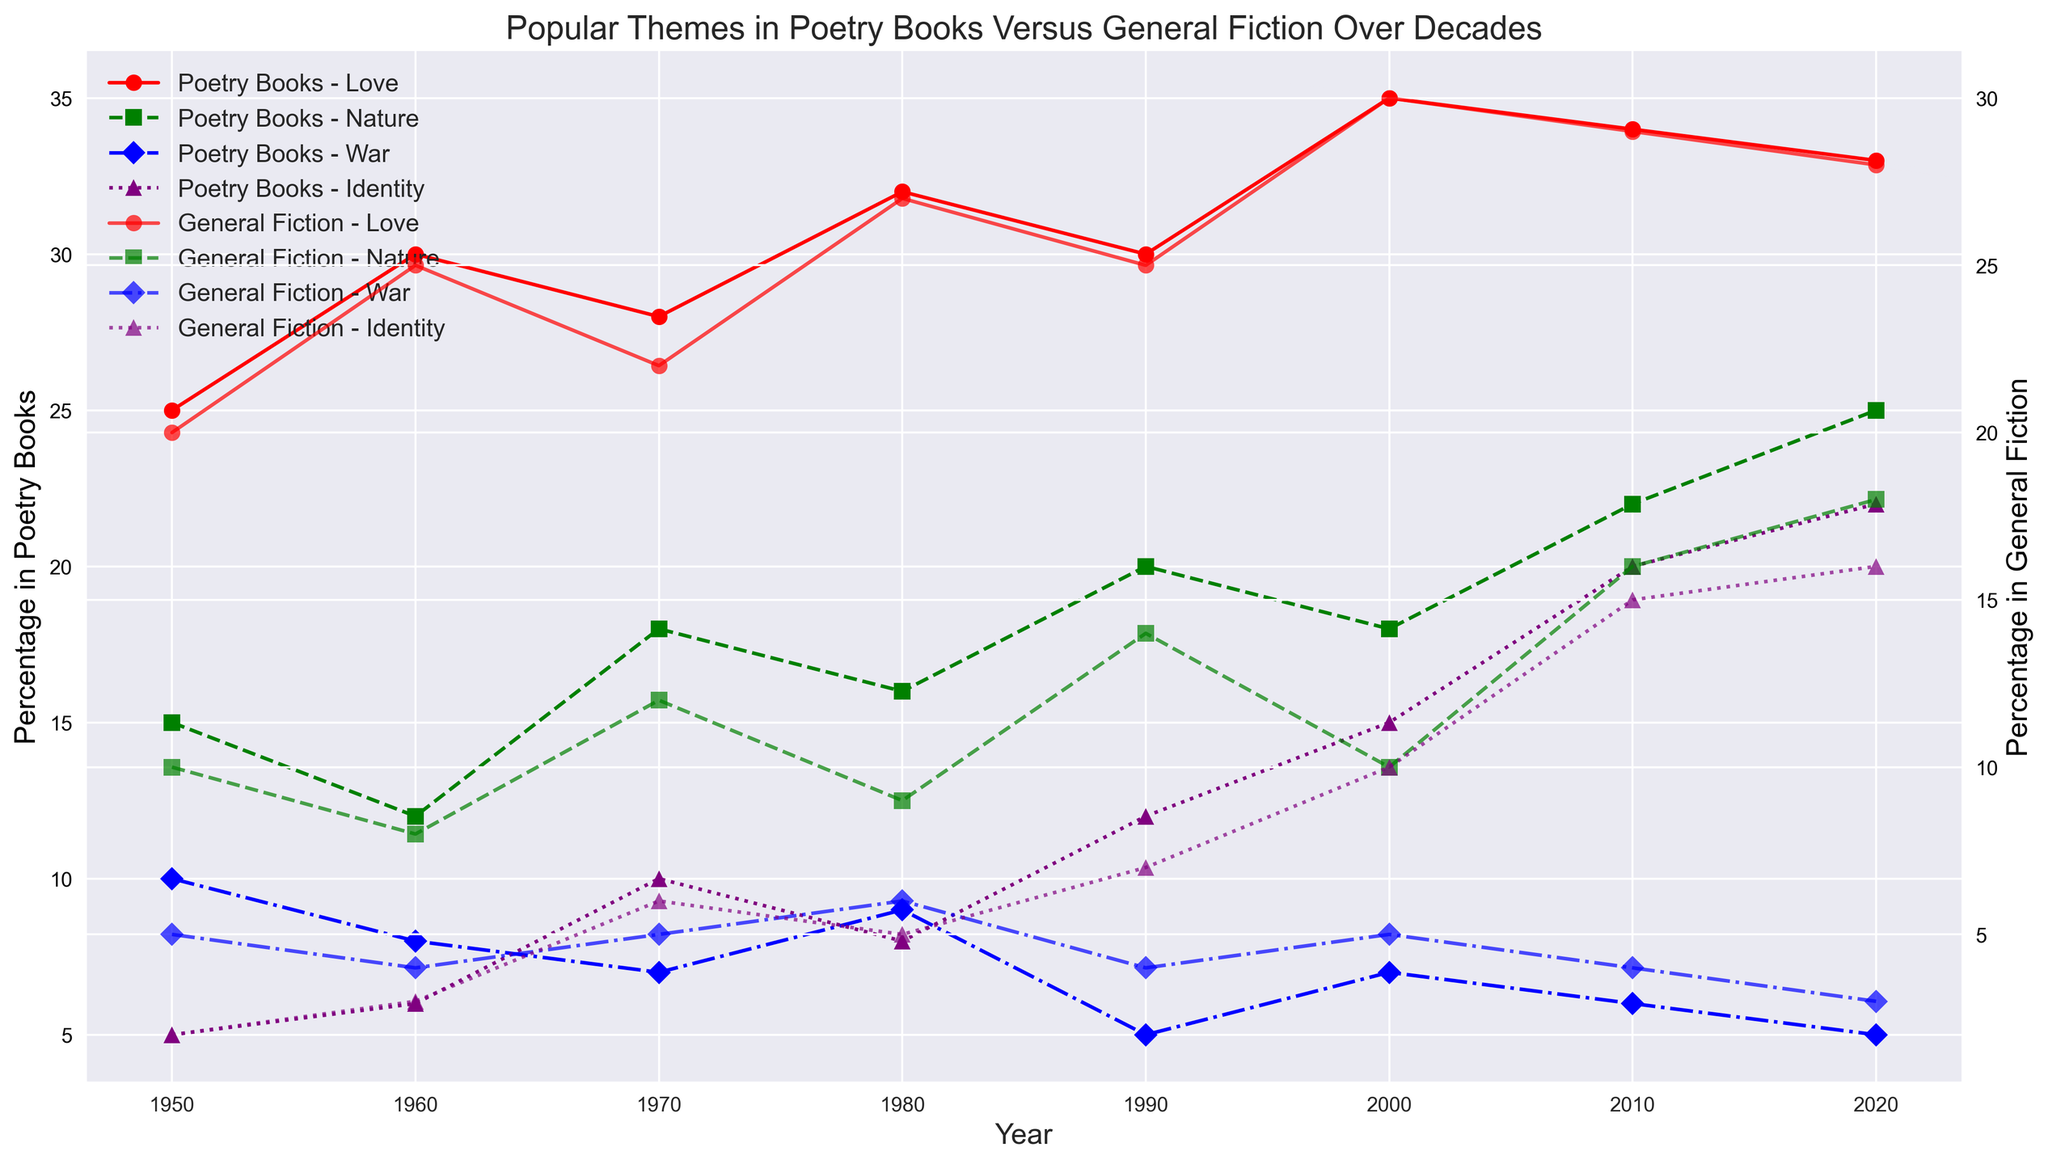What's the most popular theme in Poetry Books in 1960? To determine the most popular theme in Poetry Books in 1960, look for the theme with the highest percentage in the Poetry Books for that year. In 1960, "Love" has the highest percentage at 30%.
Answer: Love Which theme saw the biggest increase in percentage in Poetry Books from 2000 to 2010? Calculate the difference in percentage for each theme between 2000 and 2010. Love: 35-34=1, Nature: 18-22=-4, War: 7-6=1, Identity: 15-20=-5. "Identity" saw the biggest increase with a difference of -5 (from 15 to 20 percent).
Answer: Identity Did any theme in General Fiction surpass its corresponding theme in Poetry Books at any decade? Compare the percentages of each theme in General Fiction to those in Poetry Books for each decade. There is no instance where the percentage of any theme in General Fiction surpasses that in Poetry Books.
Answer: No Which theme in Poetry Books remained the most consistently popular over the decades? To find the theme that remained consistently popular, consider which theme shows relatively stable and high percentages across all decades. "Love" consistently shows high and stable percentages over the decades.
Answer: Love What is the percentage difference in “Nature” themes between Poetry Books and General Fiction in 2020? Subtract the percentage of "Nature" in General Fiction from that in Poetry Books for the year 2020. 25% (Poetry Books) - 18% (General Fiction) = 7%.
Answer: 7% Which theme in General Fiction shows an upward trend in popularity over the decades? Look for the themes in General Fiction whose percentages increase from decade to decade. "Identity" shows a clear upward trend from 1950 to 2020.
Answer: Identity Between "War" and "Identity," which theme had a greater increase in Poetry Books from 1950 to 2020? Calculate the difference in percentage for "War" and "Identity" between 1950 and 2020. War: 5 - 10 = -5, Identity: 22 - 5 = 17. "Identity" had a greater increase with a difference of 17%.
Answer: Identity In which decade did "Nature" in General Fiction reach the highest percentage? Identify the decade with the highest percentage for "Nature" in General Fiction. In 2020, "Nature" reached its highest percentage at 18%.
Answer: 2020 